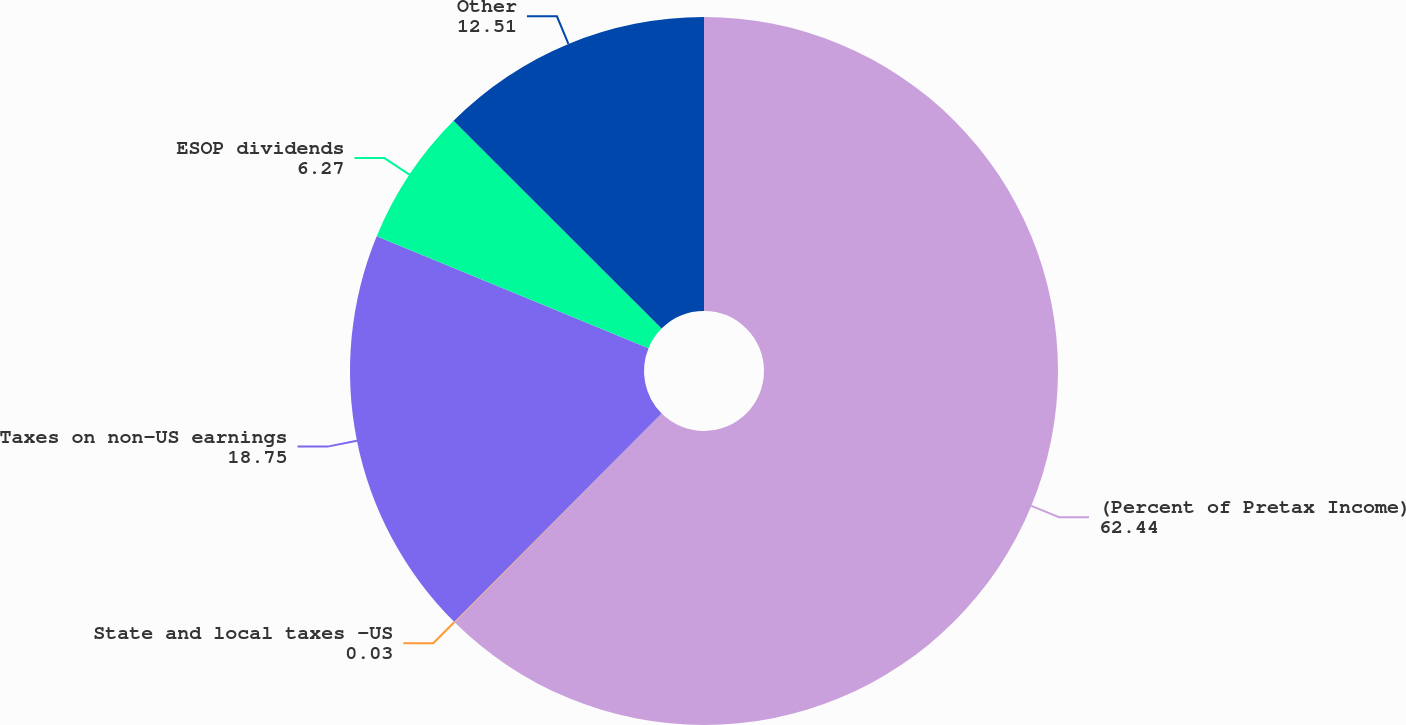Convert chart. <chart><loc_0><loc_0><loc_500><loc_500><pie_chart><fcel>(Percent of Pretax Income)<fcel>State and local taxes -US<fcel>Taxes on non-US earnings<fcel>ESOP dividends<fcel>Other<nl><fcel>62.44%<fcel>0.03%<fcel>18.75%<fcel>6.27%<fcel>12.51%<nl></chart> 